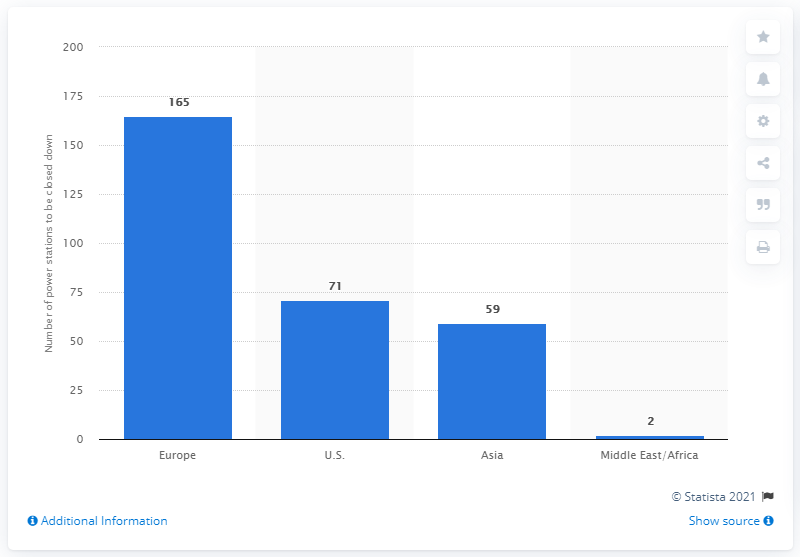Outline some significant characteristics in this image. By 2030, it is projected that 165 nuclear power stations will be closed down in Europe. 